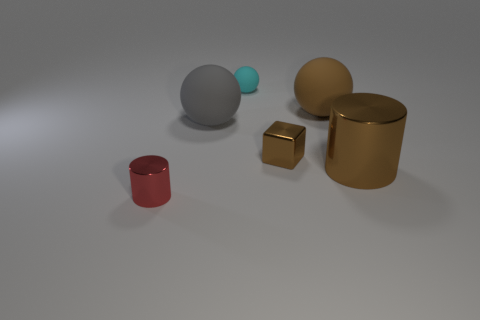There is a thing that is on the right side of the brown metallic cube and in front of the large gray rubber object; what is its size?
Provide a short and direct response. Large. Do the block and the large sphere to the right of the gray matte object have the same color?
Provide a short and direct response. Yes. What number of cyan objects are either cubes or cylinders?
Provide a short and direct response. 0. What is the shape of the big brown metallic thing?
Ensure brevity in your answer.  Cylinder. What number of other things are there of the same shape as the brown matte object?
Keep it short and to the point. 2. The cylinder that is on the left side of the gray sphere is what color?
Your answer should be compact. Red. Is the material of the gray thing the same as the big brown cylinder?
Give a very brief answer. No. What number of things are big gray things or brown objects behind the brown shiny cylinder?
Provide a short and direct response. 3. There is a shiny thing that is the same color as the tiny block; what size is it?
Give a very brief answer. Large. The tiny metallic thing right of the red cylinder has what shape?
Your answer should be very brief. Cube. 